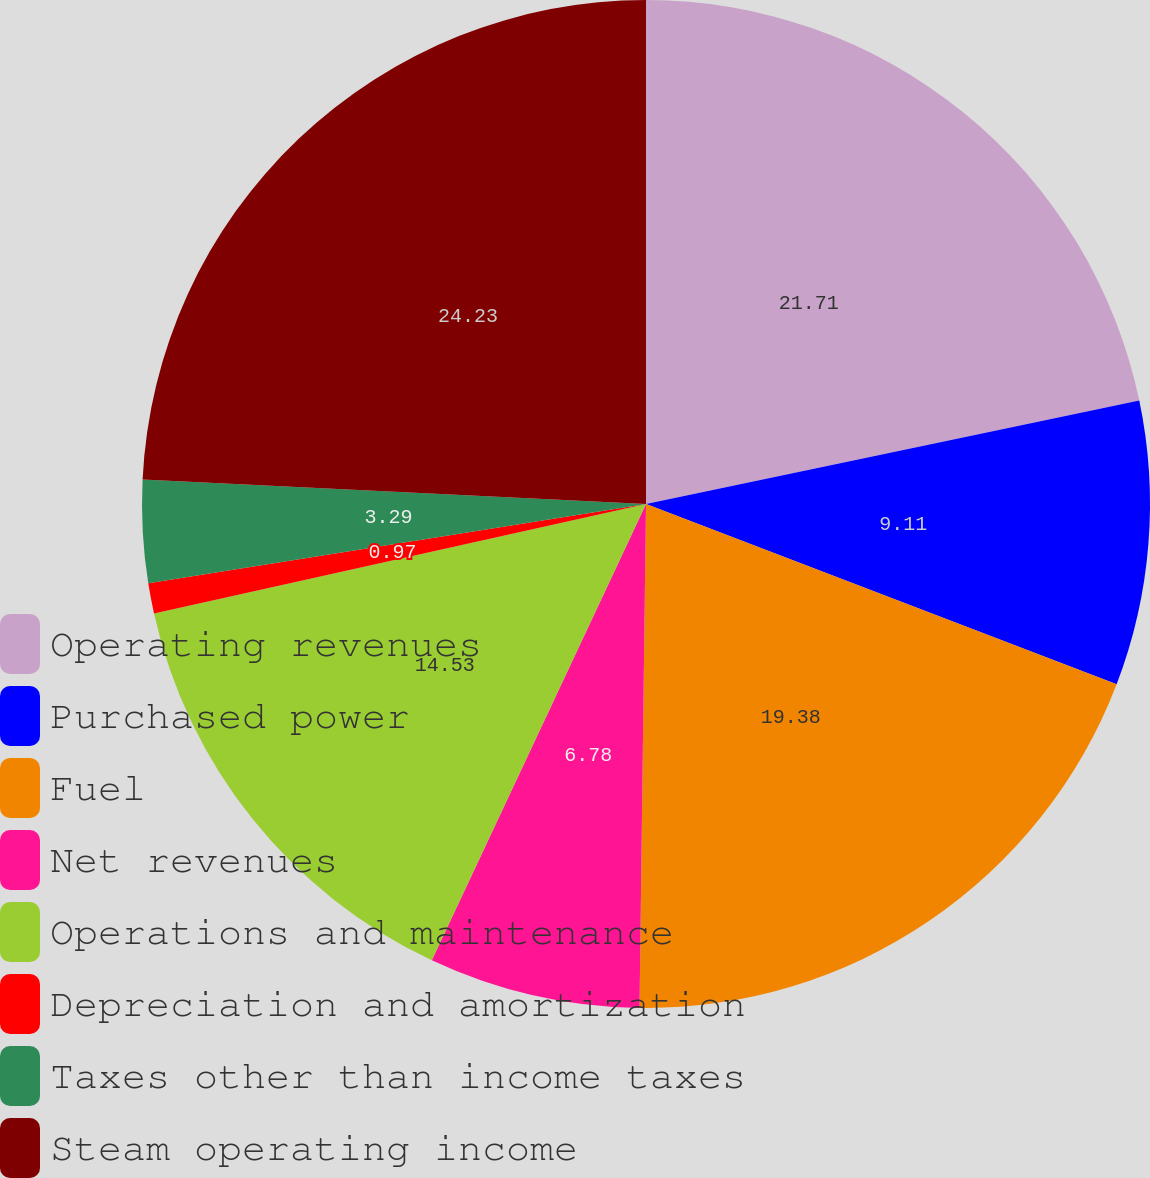Convert chart. <chart><loc_0><loc_0><loc_500><loc_500><pie_chart><fcel>Operating revenues<fcel>Purchased power<fcel>Fuel<fcel>Net revenues<fcel>Operations and maintenance<fcel>Depreciation and amortization<fcel>Taxes other than income taxes<fcel>Steam operating income<nl><fcel>21.71%<fcel>9.11%<fcel>19.38%<fcel>6.78%<fcel>14.53%<fcel>0.97%<fcel>3.29%<fcel>24.22%<nl></chart> 